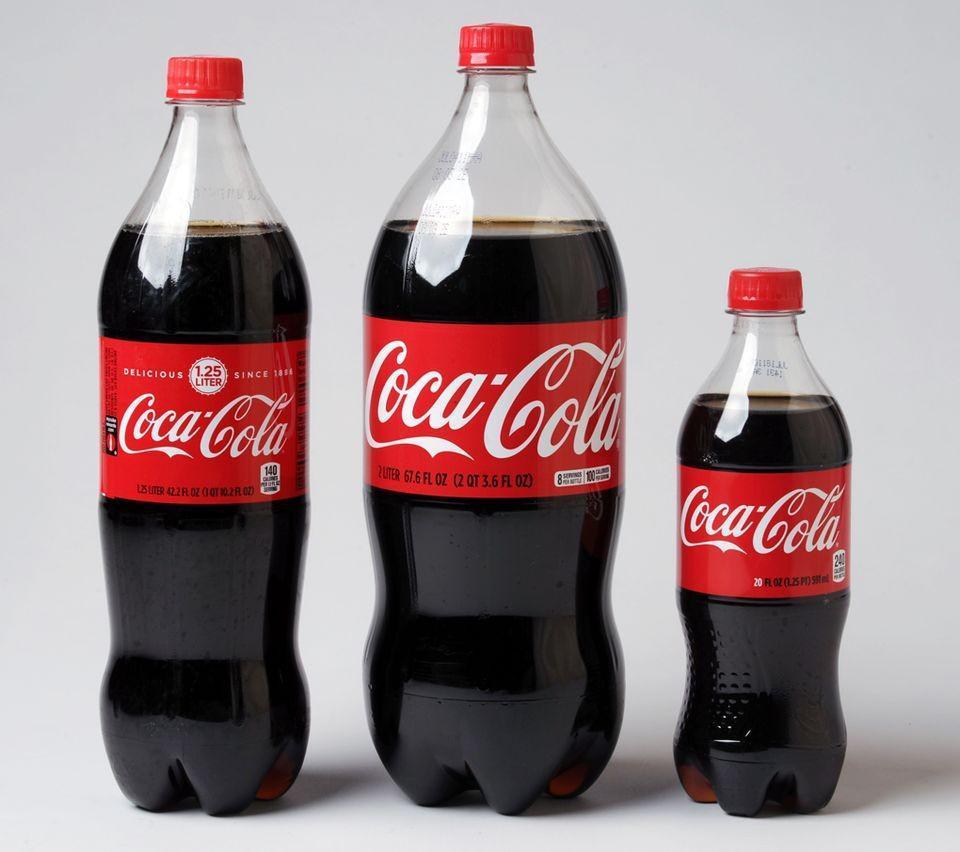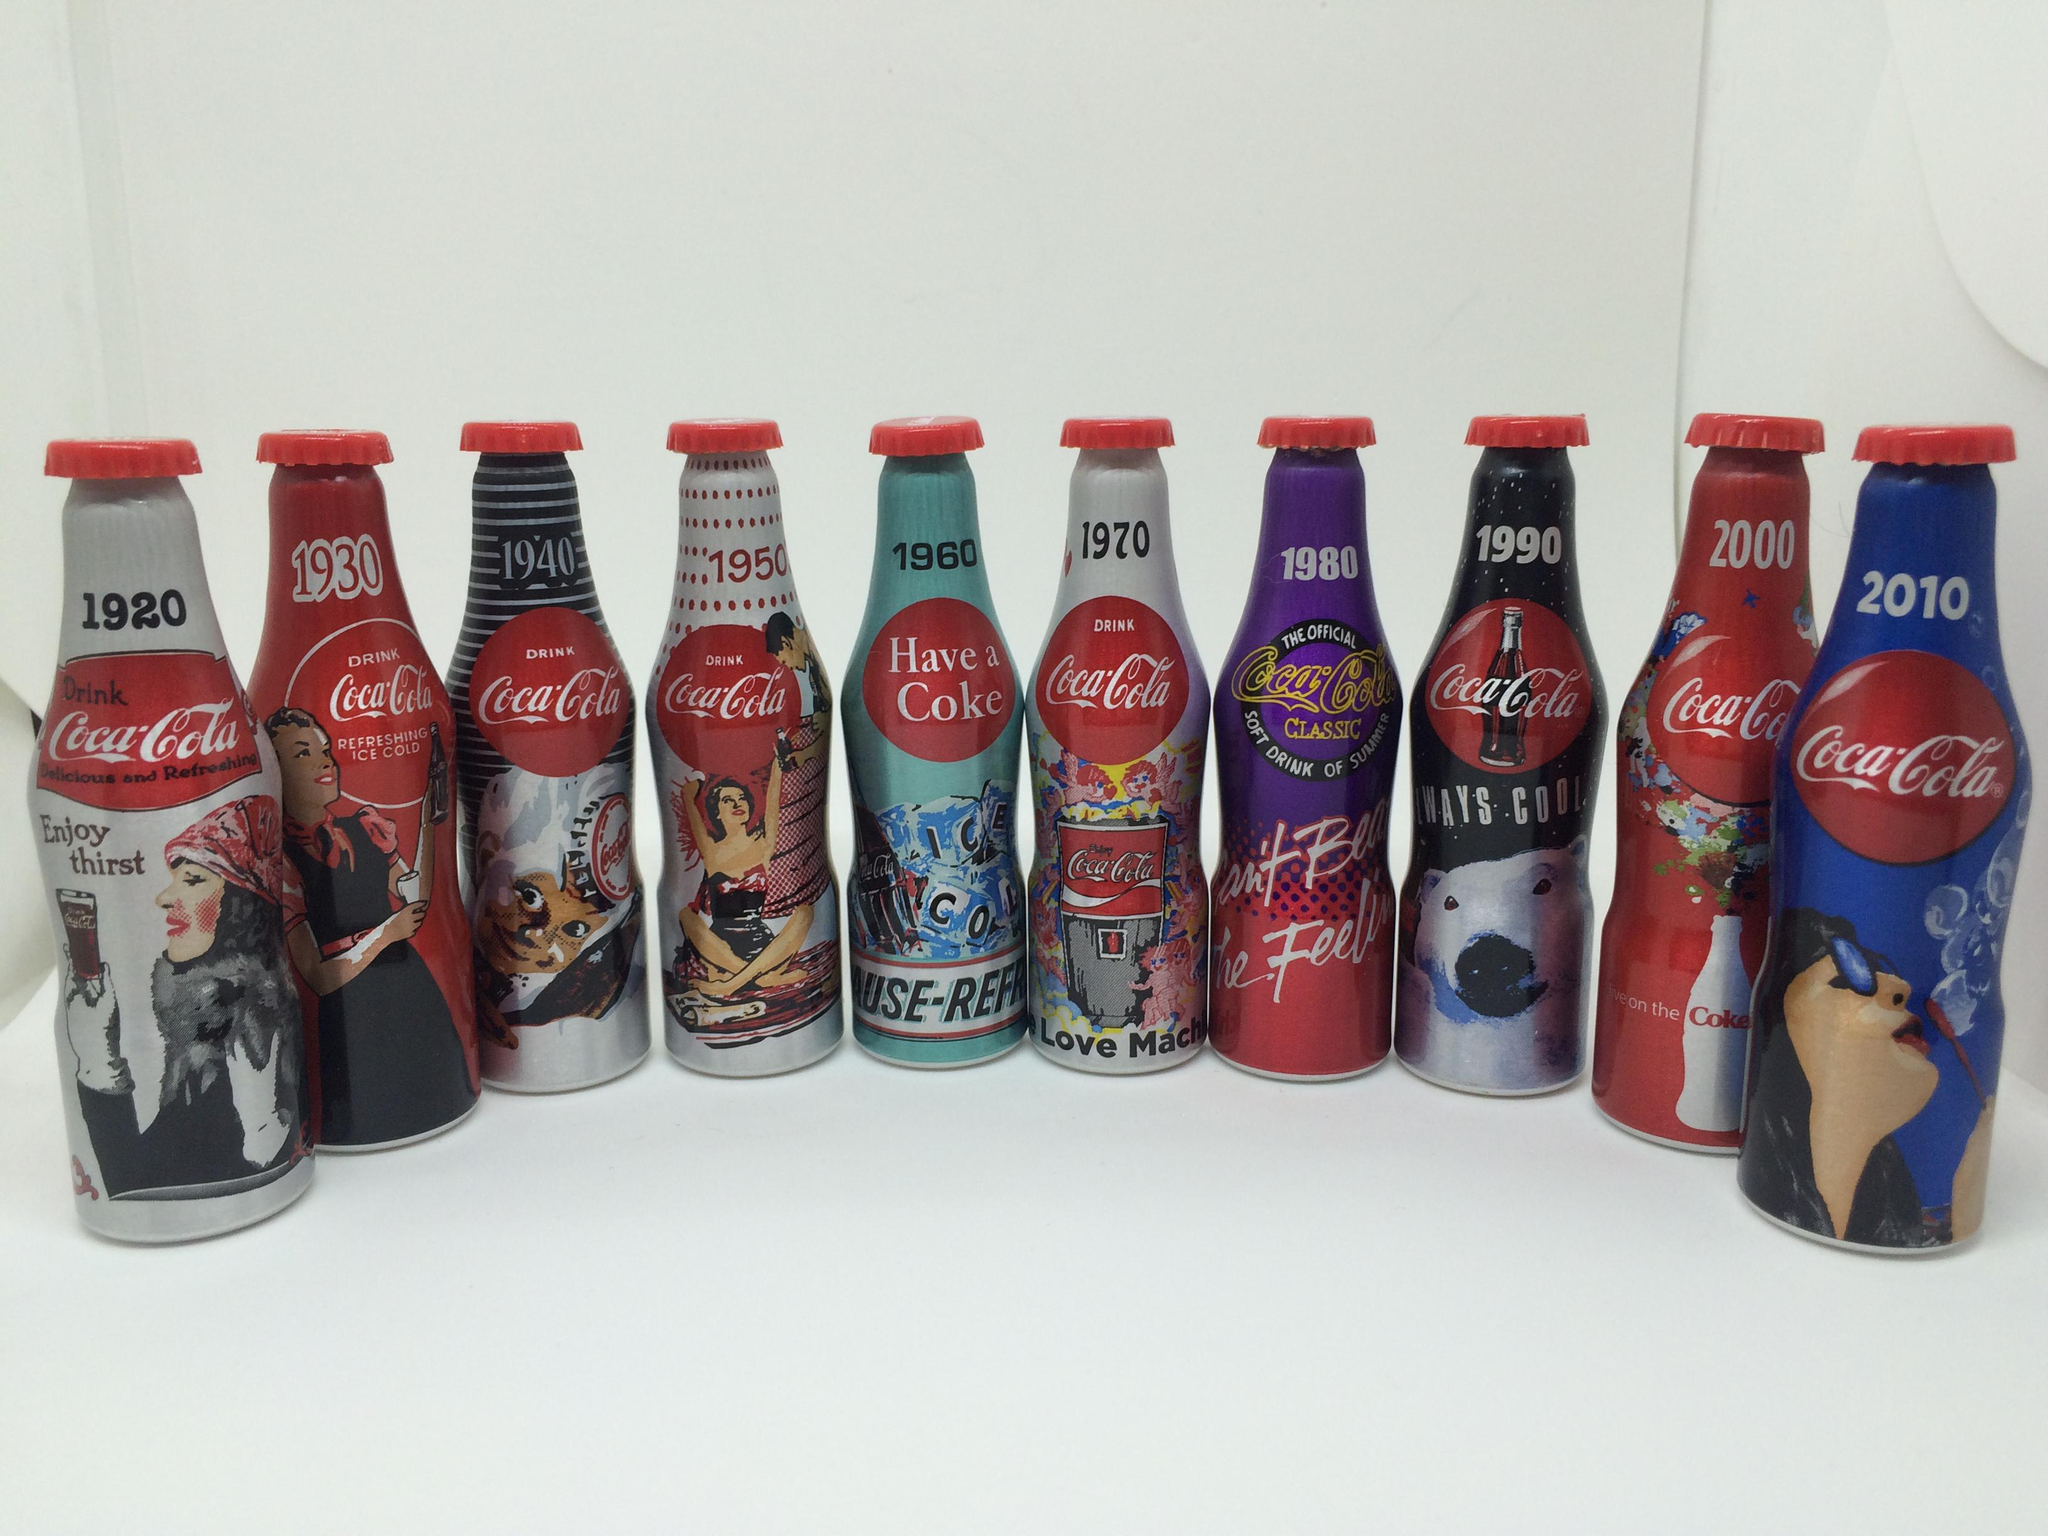The first image is the image on the left, the second image is the image on the right. For the images displayed, is the sentence "There are fewer than twelve bottles in total." factually correct? Answer yes or no. No. The first image is the image on the left, the second image is the image on the right. For the images displayed, is the sentence "The left and right image contains the same number of  bottles." factually correct? Answer yes or no. No. 